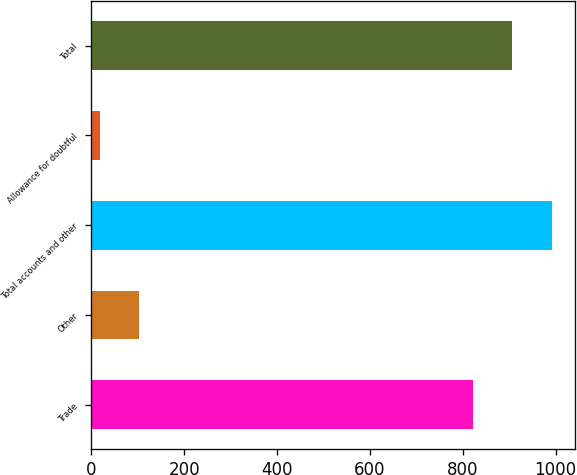<chart> <loc_0><loc_0><loc_500><loc_500><bar_chart><fcel>Trade<fcel>Other<fcel>Total accounts and other<fcel>Allowance for doubtful<fcel>Total<nl><fcel>821.7<fcel>103.48<fcel>992.46<fcel>18.1<fcel>907.08<nl></chart> 